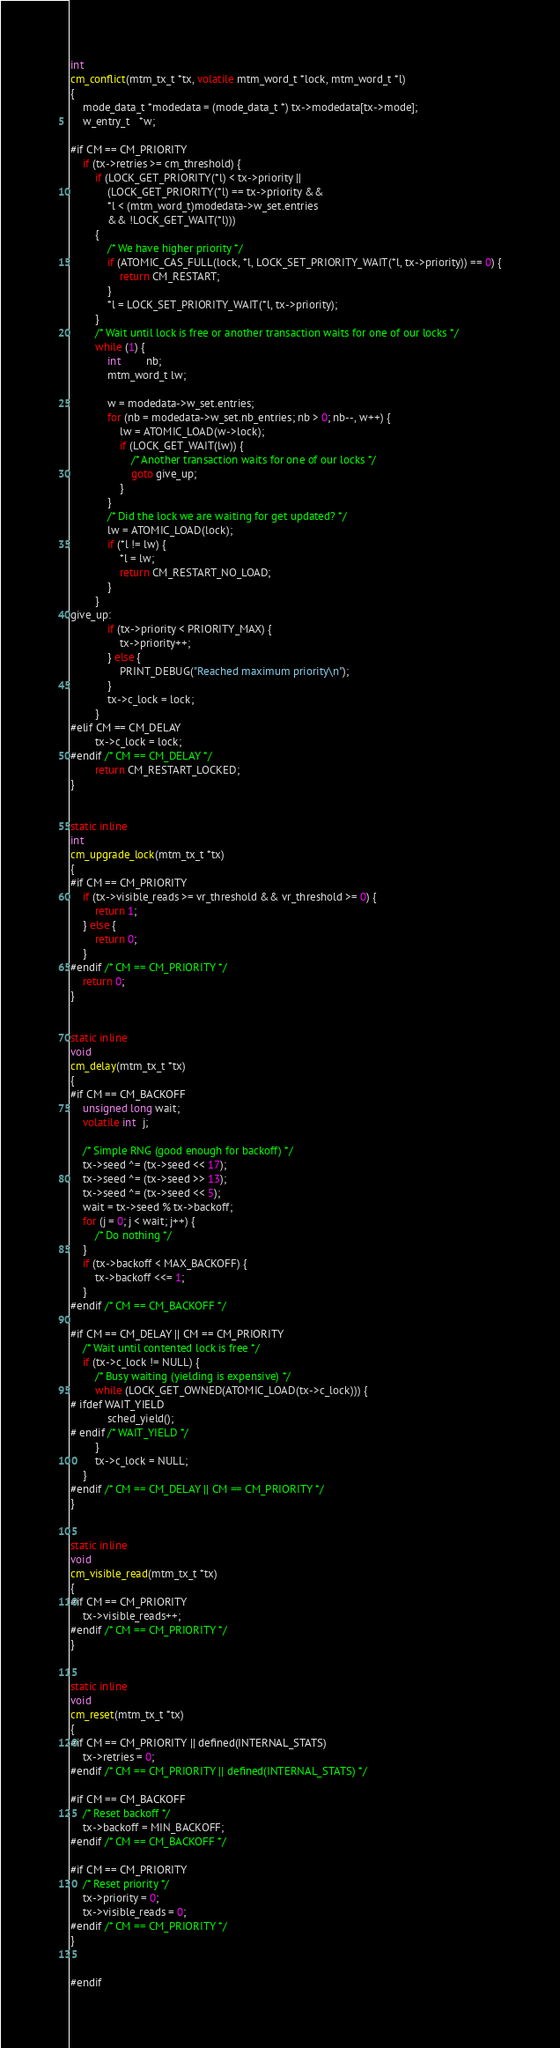<code> <loc_0><loc_0><loc_500><loc_500><_C_>int 
cm_conflict(mtm_tx_t *tx, volatile mtm_word_t *lock, mtm_word_t *l)
{
	mode_data_t *modedata = (mode_data_t *) tx->modedata[tx->mode];
	w_entry_t   *w;

#if CM == CM_PRIORITY
	if (tx->retries >= cm_threshold) {
		if (LOCK_GET_PRIORITY(*l) < tx->priority ||
			(LOCK_GET_PRIORITY(*l) == tx->priority &&
			*l < (mtm_word_t)modedata->w_set.entries
			&& !LOCK_GET_WAIT(*l))) 
		{
			/* We have higher priority */
			if (ATOMIC_CAS_FULL(lock, *l, LOCK_SET_PRIORITY_WAIT(*l, tx->priority)) == 0) {
				return CM_RESTART;
			}
			*l = LOCK_SET_PRIORITY_WAIT(*l, tx->priority);
		}
		/* Wait until lock is free or another transaction waits for one of our locks */
		while (1) {
			int        nb;
			mtm_word_t lw;

			w = modedata->w_set.entries;
			for (nb = modedata->w_set.nb_entries; nb > 0; nb--, w++) {
				lw = ATOMIC_LOAD(w->lock);
				if (LOCK_GET_WAIT(lw)) {
					/* Another transaction waits for one of our locks */
					goto give_up;
				}
			}
			/* Did the lock we are waiting for get updated? */
			lw = ATOMIC_LOAD(lock);
			if (*l != lw) {
				*l = lw;
				return CM_RESTART_NO_LOAD;
			}
		}
give_up:
			if (tx->priority < PRIORITY_MAX) {
				tx->priority++;
			} else {
				PRINT_DEBUG("Reached maximum priority\n");
			}
			tx->c_lock = lock;
		}
#elif CM == CM_DELAY
		tx->c_lock = lock;
#endif /* CM == CM_DELAY */
		return CM_RESTART_LOCKED;
}


static inline
int
cm_upgrade_lock(mtm_tx_t *tx)
{
#if CM == CM_PRIORITY
	if (tx->visible_reads >= vr_threshold && vr_threshold >= 0) {
		return 1;
	} else {
		return 0;
	}
#endif /* CM == CM_PRIORITY */
	return 0;
}


static inline
void
cm_delay(mtm_tx_t *tx)
{
#if CM == CM_BACKOFF
	unsigned long wait;
	volatile int  j;

	/* Simple RNG (good enough for backoff) */
	tx->seed ^= (tx->seed << 17);
	tx->seed ^= (tx->seed >> 13);
	tx->seed ^= (tx->seed << 5);
	wait = tx->seed % tx->backoff;
	for (j = 0; j < wait; j++) {
		/* Do nothing */
	}
	if (tx->backoff < MAX_BACKOFF) {
		tx->backoff <<= 1;
	}
#endif /* CM == CM_BACKOFF */

#if CM == CM_DELAY || CM == CM_PRIORITY
	/* Wait until contented lock is free */
	if (tx->c_lock != NULL) {
		/* Busy waiting (yielding is expensive) */
		while (LOCK_GET_OWNED(ATOMIC_LOAD(tx->c_lock))) {
# ifdef WAIT_YIELD
			sched_yield();
# endif /* WAIT_YIELD */
		}
		tx->c_lock = NULL;
	}
#endif /* CM == CM_DELAY || CM == CM_PRIORITY */
}


static inline
void
cm_visible_read(mtm_tx_t *tx)
{
#if CM == CM_PRIORITY
	tx->visible_reads++;
#endif /* CM == CM_PRIORITY */
}


static inline
void
cm_reset(mtm_tx_t *tx)
{
#if CM == CM_PRIORITY || defined(INTERNAL_STATS)
	tx->retries = 0;
#endif /* CM == CM_PRIORITY || defined(INTERNAL_STATS) */

#if CM == CM_BACKOFF
	/* Reset backoff */
	tx->backoff = MIN_BACKOFF;
#endif /* CM == CM_BACKOFF */

#if CM == CM_PRIORITY
	/* Reset priority */
	tx->priority = 0;
	tx->visible_reads = 0;
#endif /* CM == CM_PRIORITY */
}


#endif
</code> 